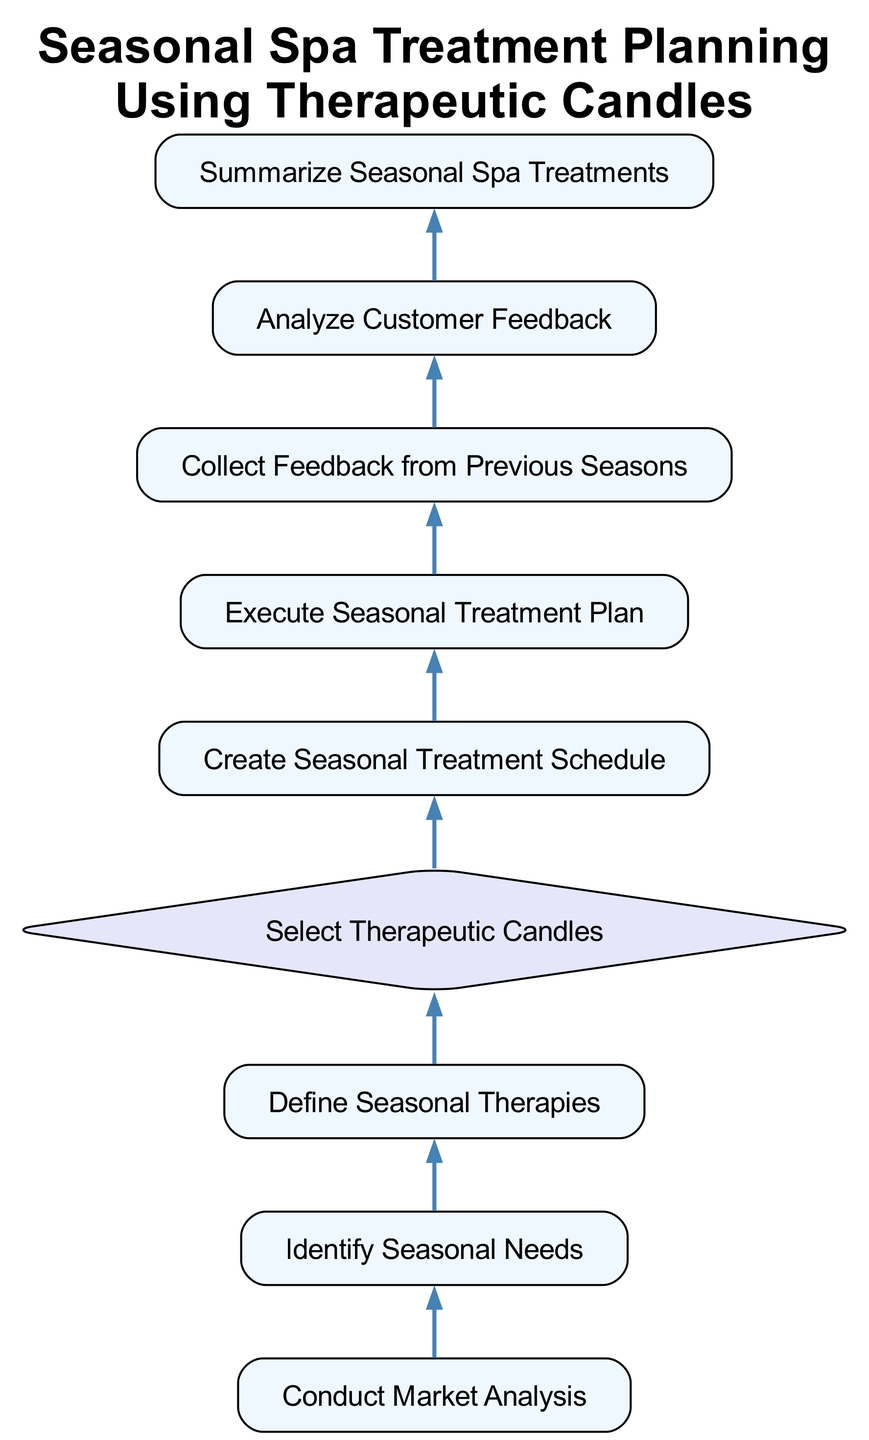What is the first step in the planning process? The first step in the planning process is to conduct market analysis. This is the starting node in the flowchart, which has no dependencies.
Answer: Conduct Market Analysis How many processes are present in the diagram? The diagram contains a total of eight process nodes. Processes are depicted in rectangular nodes, and by counting them within the flowchart, we find eight such nodes.
Answer: Eight What node follows the 'Select Therapeutic Candles' decision? After making a decision on selecting therapeutic candles, the next step is to create a seasonal treatment schedule. The diagram shows an arrow pointing to this node from the decision node.
Answer: Create Seasonal Treatment Schedule What is the relationship between 'Analyze Customer Feedback' and 'Collect Feedback from Previous Seasons'? 'Analyze Customer Feedback' depends on 'Collect Feedback from Previous Seasons,' which means that feedback must be collected before it can be analyzed. This relationship is evident from the directed edge connecting the two process nodes.
Answer: Analyze Customer Feedback depends on Collect Feedback from Previous Seasons If 'Define Seasonal Therapies' is completed, what is the next node? Once 'Define Seasonal Therapies' is completed, the next action is to select therapeutic candles. The flow from one process to another is established by the directed connection in the diagram.
Answer: Select Therapeutic Candles How many decisions are present in the diagram? There is one decision node in the diagram, indicated by the diamond shape. Counting the nodes, we identify only the 'Select Therapeutic Candles' decision.
Answer: One After conducting market analysis, what is the immediate subsequent step? The immediate subsequent step after conducting market analysis is to identify seasonal needs. This can be seen by following the directed flow from the market analysis node to the seasonal needs node.
Answer: Identify Seasonal Needs Which process leads to the execution of the seasonal treatment plan? The process that leads to the execution of the seasonal treatment plan is the creation of the seasonal treatment schedule. The diagram indicates that this is a prerequisite step.
Answer: Create Seasonal Treatment Schedule 